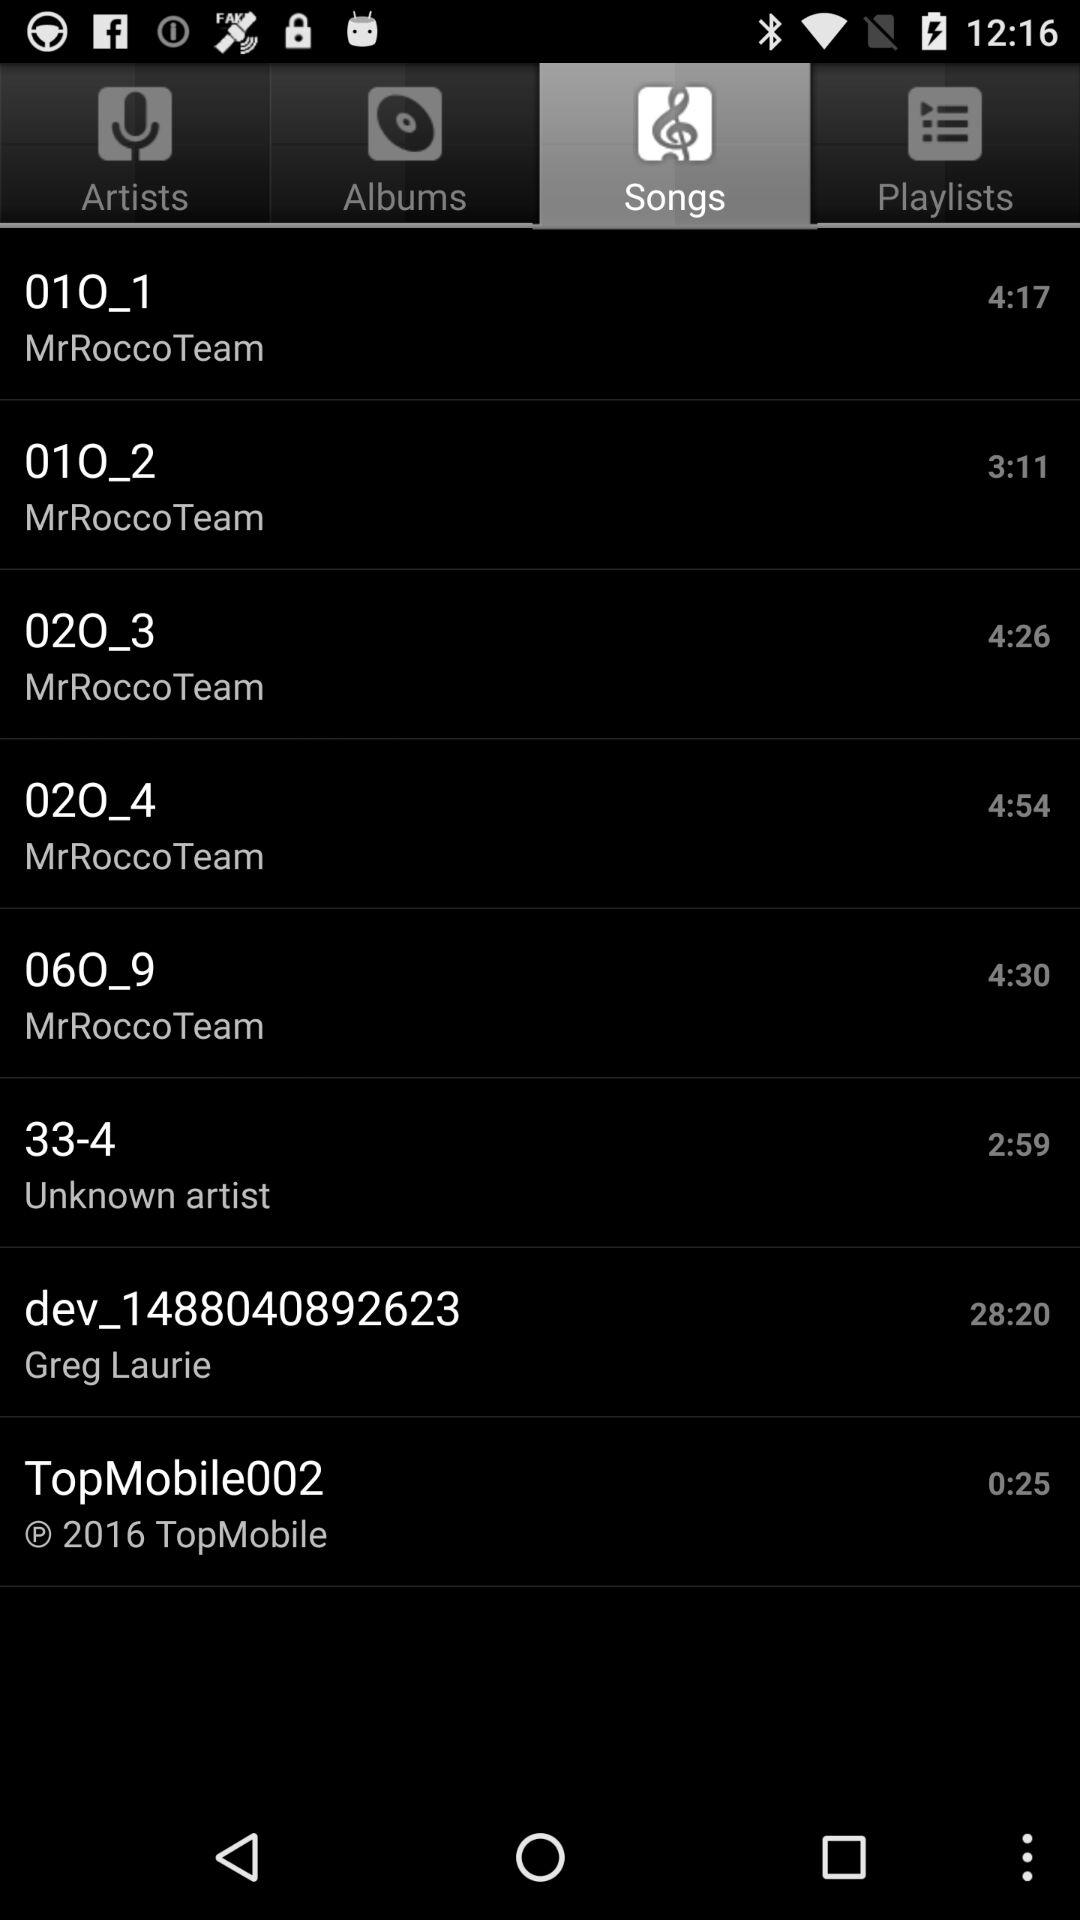What is the name of the singer of the song "02O_4"? The name of the singer is "MrRoccoTeam". 